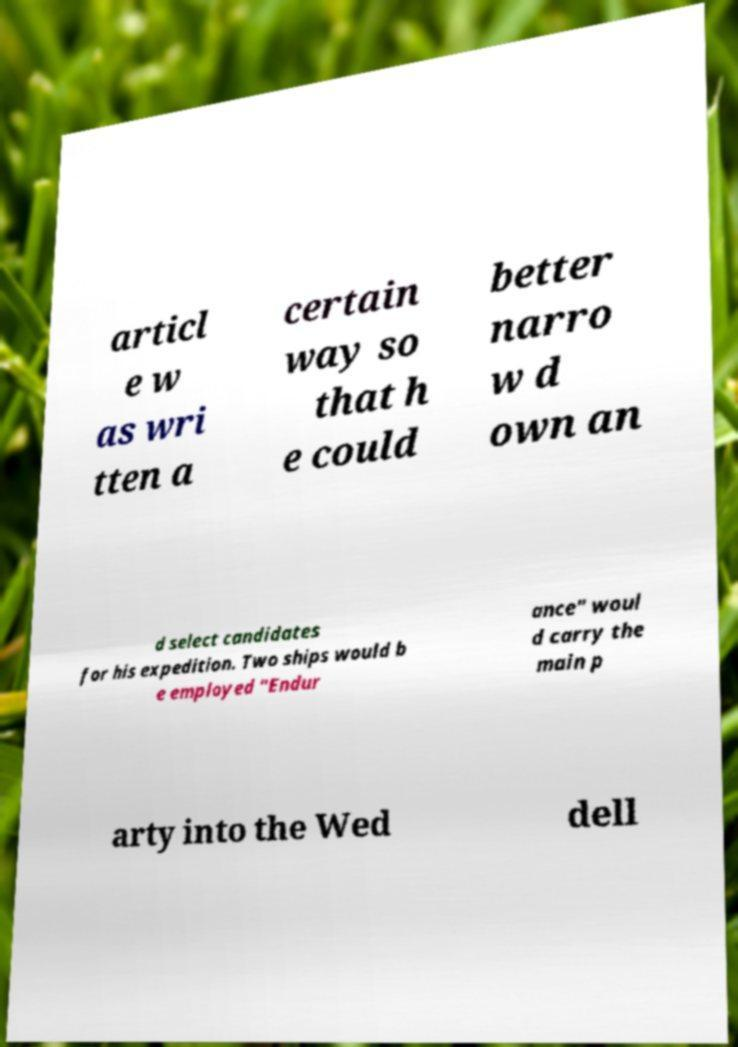Could you assist in decoding the text presented in this image and type it out clearly? articl e w as wri tten a certain way so that h e could better narro w d own an d select candidates for his expedition. Two ships would b e employed "Endur ance" woul d carry the main p arty into the Wed dell 